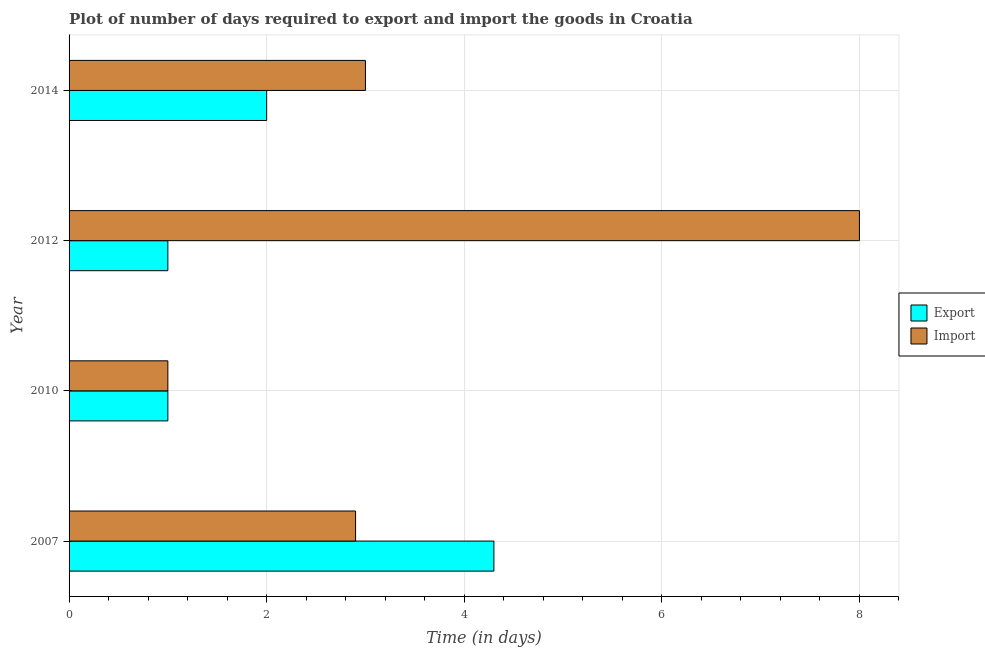How many groups of bars are there?
Keep it short and to the point. 4. Are the number of bars per tick equal to the number of legend labels?
Your answer should be compact. Yes. What is the time required to export in 2007?
Offer a terse response. 4.3. Across all years, what is the maximum time required to export?
Give a very brief answer. 4.3. Across all years, what is the minimum time required to export?
Ensure brevity in your answer.  1. In which year was the time required to export maximum?
Make the answer very short. 2007. In which year was the time required to import minimum?
Give a very brief answer. 2010. What is the average time required to import per year?
Ensure brevity in your answer.  3.73. In the year 2014, what is the difference between the time required to export and time required to import?
Make the answer very short. -1. Is the time required to import in 2010 less than that in 2014?
Keep it short and to the point. Yes. Is the sum of the time required to export in 2010 and 2012 greater than the maximum time required to import across all years?
Your answer should be compact. No. What does the 2nd bar from the top in 2007 represents?
Ensure brevity in your answer.  Export. What does the 2nd bar from the bottom in 2007 represents?
Provide a short and direct response. Import. What is the difference between two consecutive major ticks on the X-axis?
Make the answer very short. 2. Does the graph contain grids?
Your response must be concise. Yes. Where does the legend appear in the graph?
Ensure brevity in your answer.  Center right. How many legend labels are there?
Offer a terse response. 2. What is the title of the graph?
Your answer should be very brief. Plot of number of days required to export and import the goods in Croatia. Does "Net National savings" appear as one of the legend labels in the graph?
Make the answer very short. No. What is the label or title of the X-axis?
Provide a succinct answer. Time (in days). What is the Time (in days) of Export in 2007?
Make the answer very short. 4.3. What is the Time (in days) of Export in 2010?
Your response must be concise. 1. What is the Time (in days) in Import in 2010?
Make the answer very short. 1. What is the Time (in days) in Import in 2012?
Give a very brief answer. 8. What is the Time (in days) of Export in 2014?
Offer a very short reply. 2. What is the Time (in days) in Import in 2014?
Provide a short and direct response. 3. Across all years, what is the maximum Time (in days) in Export?
Make the answer very short. 4.3. What is the total Time (in days) in Import in the graph?
Provide a succinct answer. 14.9. What is the difference between the Time (in days) of Export in 2007 and that in 2010?
Your answer should be compact. 3.3. What is the difference between the Time (in days) in Import in 2007 and that in 2010?
Your answer should be very brief. 1.9. What is the difference between the Time (in days) in Import in 2007 and that in 2012?
Provide a succinct answer. -5.1. What is the difference between the Time (in days) in Import in 2010 and that in 2012?
Provide a short and direct response. -7. What is the difference between the Time (in days) in Import in 2010 and that in 2014?
Keep it short and to the point. -2. What is the difference between the Time (in days) of Import in 2012 and that in 2014?
Offer a terse response. 5. What is the difference between the Time (in days) in Export in 2007 and the Time (in days) in Import in 2010?
Provide a short and direct response. 3.3. What is the difference between the Time (in days) in Export in 2007 and the Time (in days) in Import in 2012?
Provide a succinct answer. -3.7. What is the difference between the Time (in days) of Export in 2007 and the Time (in days) of Import in 2014?
Your response must be concise. 1.3. What is the difference between the Time (in days) of Export in 2010 and the Time (in days) of Import in 2012?
Provide a short and direct response. -7. What is the difference between the Time (in days) of Export in 2010 and the Time (in days) of Import in 2014?
Give a very brief answer. -2. What is the average Time (in days) of Export per year?
Your answer should be compact. 2.08. What is the average Time (in days) in Import per year?
Offer a very short reply. 3.73. In the year 2007, what is the difference between the Time (in days) of Export and Time (in days) of Import?
Give a very brief answer. 1.4. In the year 2010, what is the difference between the Time (in days) of Export and Time (in days) of Import?
Ensure brevity in your answer.  0. In the year 2014, what is the difference between the Time (in days) in Export and Time (in days) in Import?
Ensure brevity in your answer.  -1. What is the ratio of the Time (in days) in Import in 2007 to that in 2010?
Ensure brevity in your answer.  2.9. What is the ratio of the Time (in days) of Import in 2007 to that in 2012?
Your answer should be compact. 0.36. What is the ratio of the Time (in days) of Export in 2007 to that in 2014?
Your answer should be compact. 2.15. What is the ratio of the Time (in days) in Import in 2007 to that in 2014?
Give a very brief answer. 0.97. What is the ratio of the Time (in days) in Export in 2010 to that in 2012?
Provide a short and direct response. 1. What is the ratio of the Time (in days) in Import in 2010 to that in 2012?
Your answer should be very brief. 0.12. What is the ratio of the Time (in days) in Export in 2010 to that in 2014?
Offer a terse response. 0.5. What is the ratio of the Time (in days) in Import in 2012 to that in 2014?
Offer a terse response. 2.67. What is the difference between the highest and the second highest Time (in days) in Import?
Provide a succinct answer. 5. What is the difference between the highest and the lowest Time (in days) in Export?
Offer a very short reply. 3.3. 